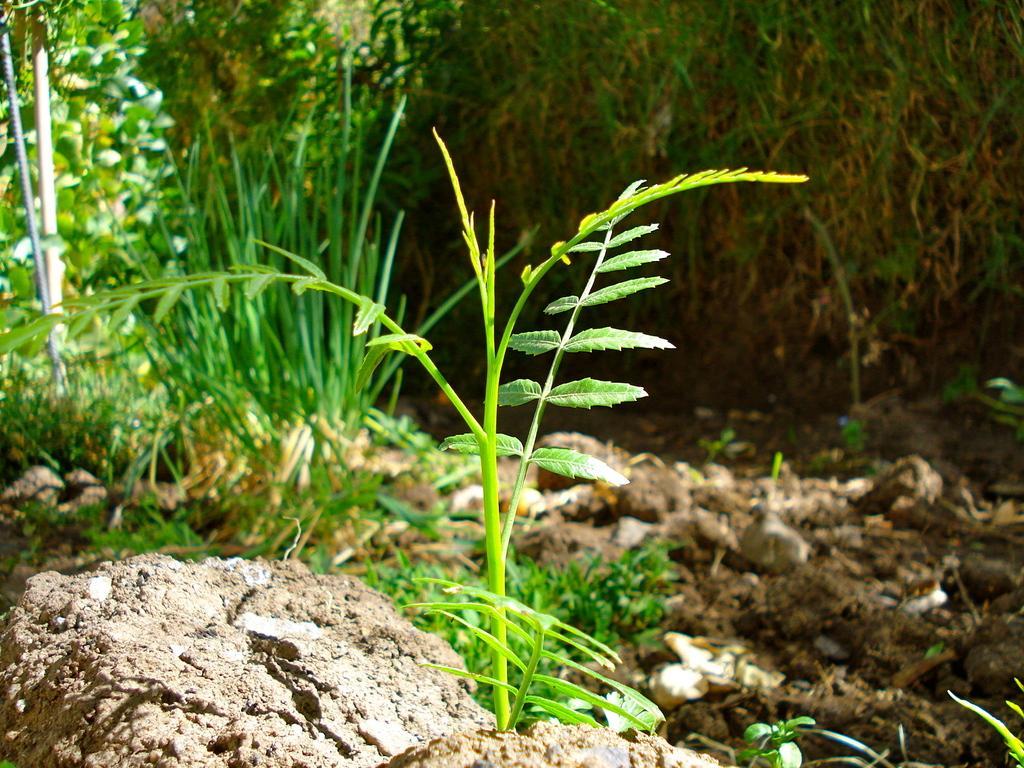How would you summarize this image in a sentence or two? In the center of the image we can see a plant. In the background, we can see the grass and soil. 